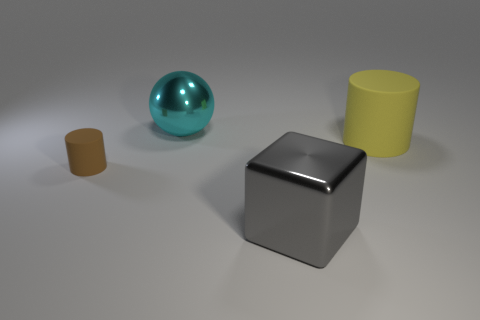There is a large thing behind the big cylinder; what is it made of?
Provide a short and direct response. Metal. There is a big metal thing that is in front of the brown matte cylinder; does it have the same shape as the large thing to the right of the big gray block?
Offer a very short reply. No. Is there a tiny yellow metallic cube?
Provide a succinct answer. No. There is a big object that is the same shape as the small brown rubber object; what is its material?
Give a very brief answer. Rubber. Are there any large spheres in front of the yellow rubber cylinder?
Your answer should be compact. No. Is the material of the thing that is behind the big yellow object the same as the large gray thing?
Offer a very short reply. Yes. Is there another shiny sphere of the same color as the metal sphere?
Keep it short and to the point. No. What shape is the brown matte object?
Offer a terse response. Cylinder. There is a matte thing that is on the right side of the large metal thing behind the large gray metallic block; what is its color?
Provide a short and direct response. Yellow. How big is the thing that is to the left of the cyan metallic ball?
Your response must be concise. Small. 